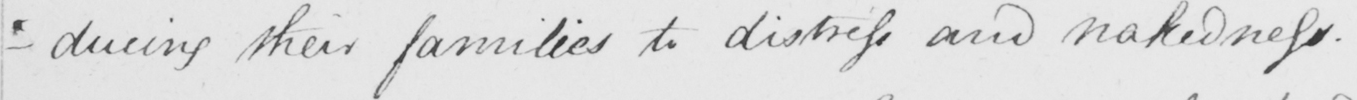Can you tell me what this handwritten text says? -ducing their families to distress and nakedness . 